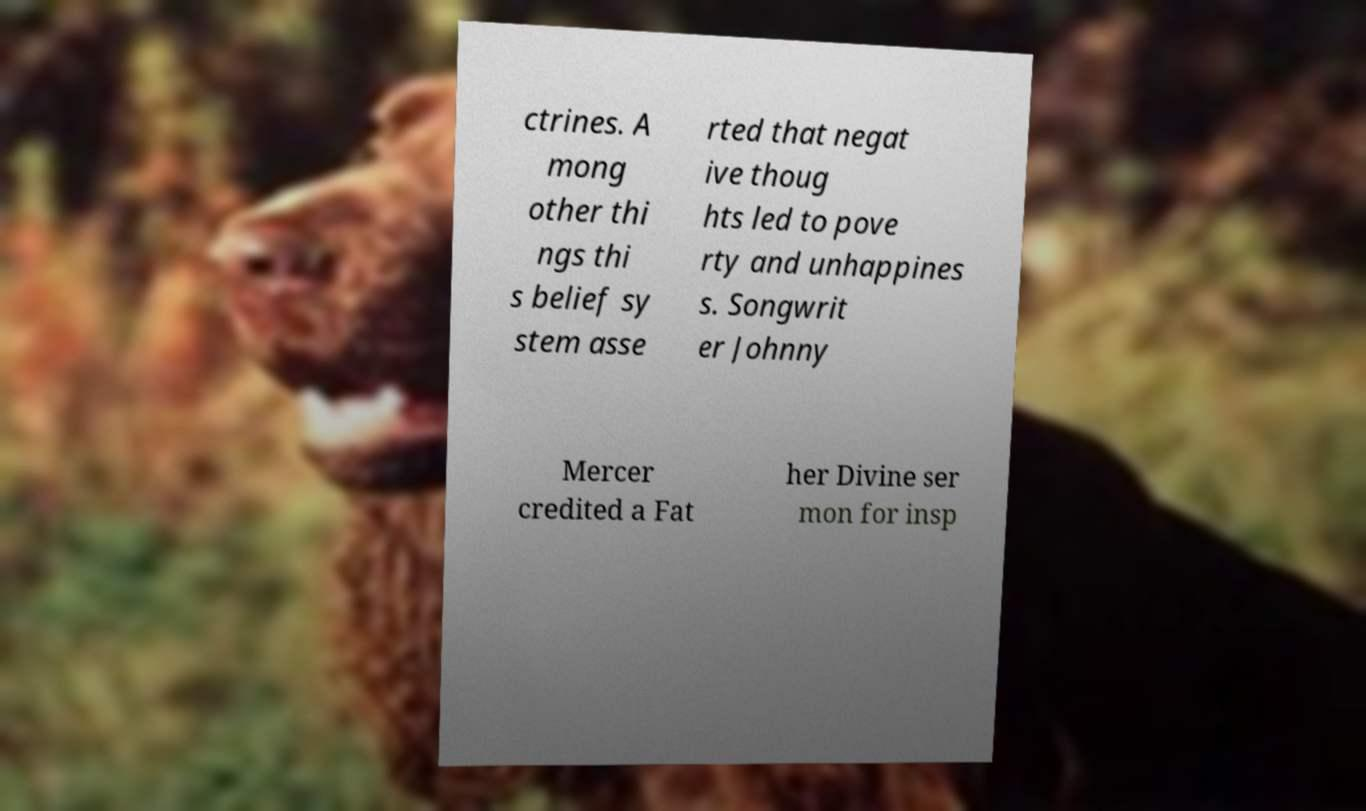I need the written content from this picture converted into text. Can you do that? ctrines. A mong other thi ngs thi s belief sy stem asse rted that negat ive thoug hts led to pove rty and unhappines s. Songwrit er Johnny Mercer credited a Fat her Divine ser mon for insp 